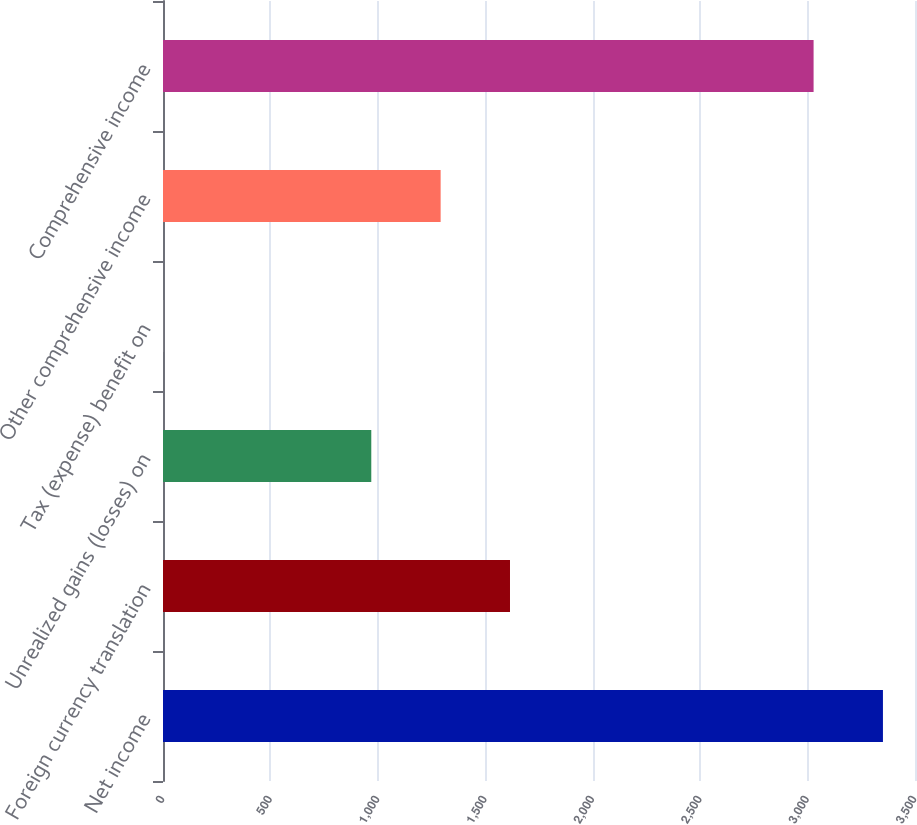Convert chart to OTSL. <chart><loc_0><loc_0><loc_500><loc_500><bar_chart><fcel>Net income<fcel>Foreign currency translation<fcel>Unrealized gains (losses) on<fcel>Tax (expense) benefit on<fcel>Other comprehensive income<fcel>Comprehensive income<nl><fcel>3350.8<fcel>1615<fcel>969.4<fcel>1<fcel>1292.2<fcel>3028<nl></chart> 